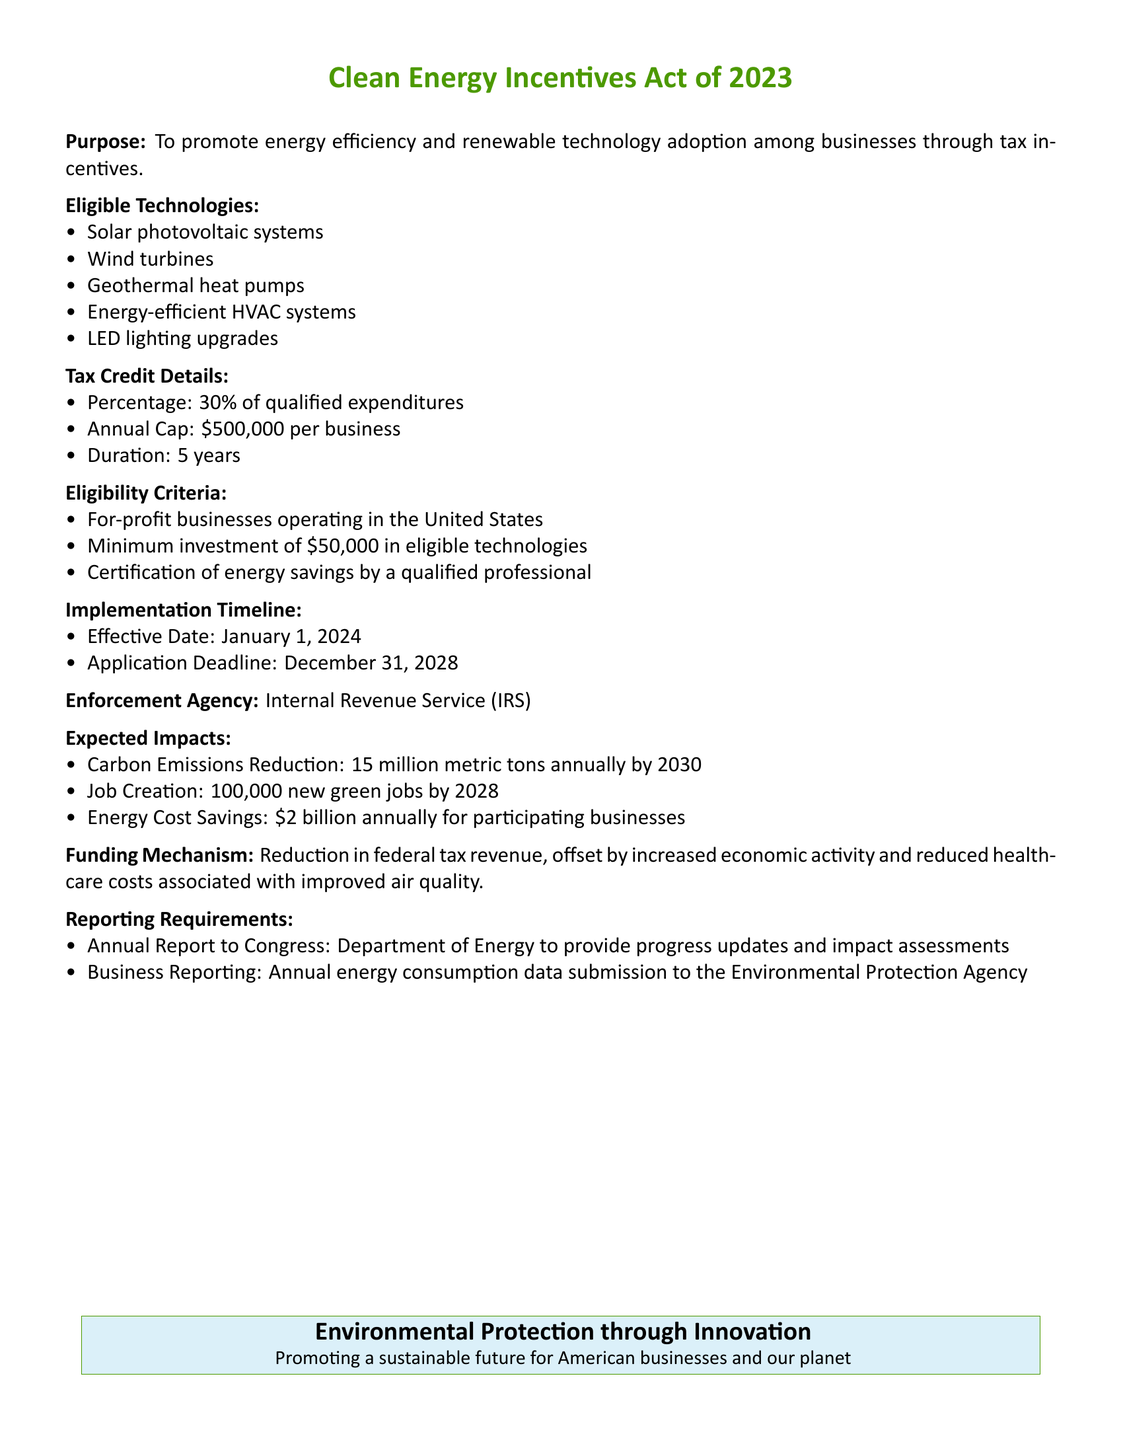What is the purpose of the Clean Energy Incentives Act of 2023? The purpose of the Act is to promote energy efficiency and renewable technology adoption among businesses through tax incentives.
Answer: To promote energy efficiency and renewable technology adoption among businesses through tax incentives What is the percentage of the tax credit offered under this bill? The tax credit offered is a percentage of qualified expenditures stated in the document.
Answer: 30% What is the annual cap for the tax credit per business? The document specifies an annual cap on the tax credit that businesses can receive.
Answer: $500,000 What is the minimum investment required for eligibility? The document outlines the requirements businesses must meet to qualify, including the minimum investment.
Answer: $50,000 When is the application deadline for the tax credits? The bill states the last day to apply for the tax credits.
Answer: December 31, 2028 Which agency is responsible for enforcement of this bill? The document identifies an agency designated to enforce the provisions of the Act.
Answer: Internal Revenue Service (IRS) How many metric tons of carbon emissions are expected to be reduced annually by 2030? The bill predicts a specific reduction in carbon emissions as part of its expected impacts.
Answer: 15 million metric tons What is the expected job creation outcome by 2028? The bill outlines a projected number of new jobs resulting from the implementation of the Act.
Answer: 100,000 new green jobs What will the annual energy cost savings be for participating businesses? The document provides a figure representing the total savings for those businesses that participate in the program.
Answer: $2 billion Who is responsible for providing progress updates and impact assessments to Congress? The document specifies which department will handle annual reporting to Congress regarding the bill's impacts.
Answer: Department of Energy 